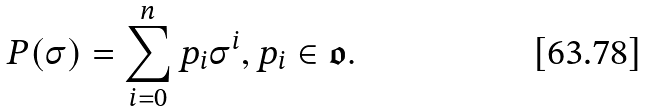<formula> <loc_0><loc_0><loc_500><loc_500>P ( \sigma ) = \sum _ { i = 0 } ^ { n } p _ { i } \sigma ^ { i } , p _ { i } \in \mathfrak { o } .</formula> 